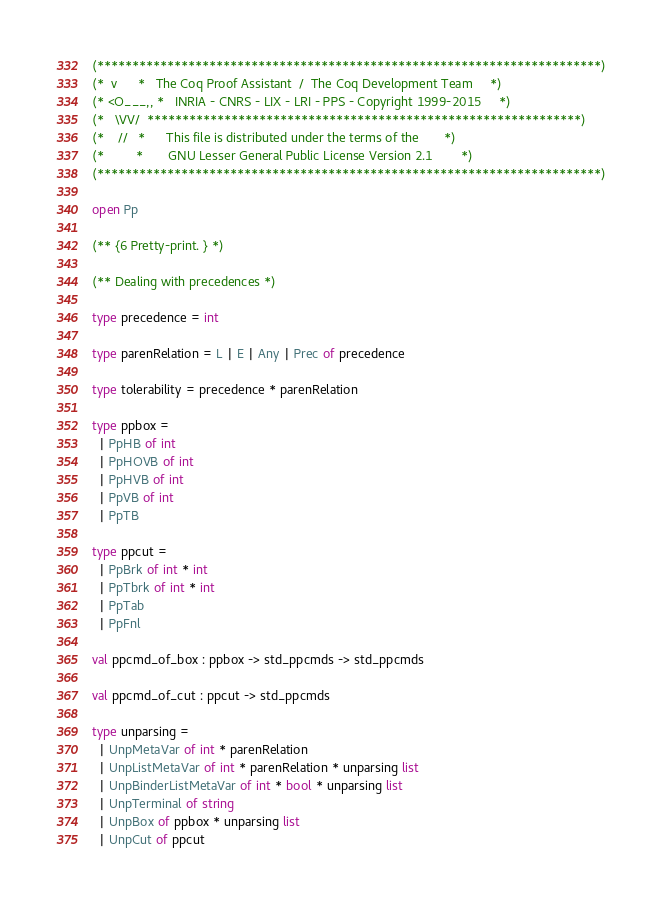Convert code to text. <code><loc_0><loc_0><loc_500><loc_500><_OCaml_>(************************************************************************)
(*  v      *   The Coq Proof Assistant  /  The Coq Development Team     *)
(* <O___,, *   INRIA - CNRS - LIX - LRI - PPS - Copyright 1999-2015     *)
(*   \VV/  **************************************************************)
(*    //   *      This file is distributed under the terms of the       *)
(*         *       GNU Lesser General Public License Version 2.1        *)
(************************************************************************)

open Pp

(** {6 Pretty-print. } *)

(** Dealing with precedences *)

type precedence = int

type parenRelation = L | E | Any | Prec of precedence

type tolerability = precedence * parenRelation

type ppbox =
  | PpHB of int
  | PpHOVB of int
  | PpHVB of int
  | PpVB of int
  | PpTB

type ppcut =
  | PpBrk of int * int
  | PpTbrk of int * int
  | PpTab
  | PpFnl

val ppcmd_of_box : ppbox -> std_ppcmds -> std_ppcmds

val ppcmd_of_cut : ppcut -> std_ppcmds

type unparsing =
  | UnpMetaVar of int * parenRelation
  | UnpListMetaVar of int * parenRelation * unparsing list
  | UnpBinderListMetaVar of int * bool * unparsing list
  | UnpTerminal of string
  | UnpBox of ppbox * unparsing list
  | UnpCut of ppcut
</code> 